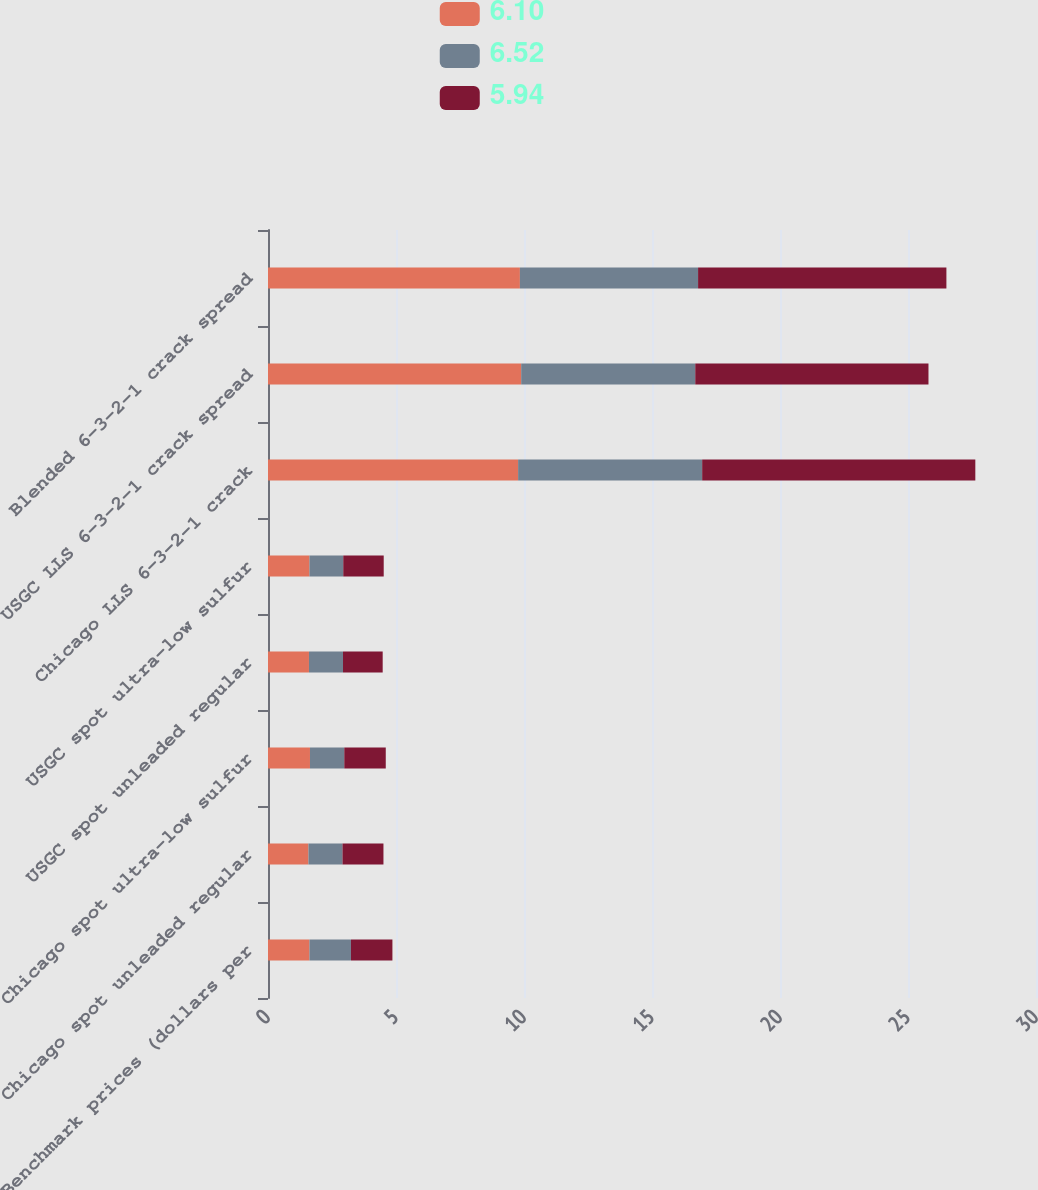Convert chart to OTSL. <chart><loc_0><loc_0><loc_500><loc_500><stacked_bar_chart><ecel><fcel>Benchmark prices (dollars per<fcel>Chicago spot unleaded regular<fcel>Chicago spot ultra-low sulfur<fcel>USGC spot unleaded regular<fcel>USGC spot ultra-low sulfur<fcel>Chicago LLS 6-3-2-1 crack<fcel>USGC LLS 6-3-2-1 crack spread<fcel>Blended 6-3-2-1 crack spread<nl><fcel>6.1<fcel>1.62<fcel>1.58<fcel>1.64<fcel>1.6<fcel>1.62<fcel>9.77<fcel>9.89<fcel>9.84<nl><fcel>6.52<fcel>1.62<fcel>1.33<fcel>1.34<fcel>1.33<fcel>1.32<fcel>7.19<fcel>6.8<fcel>6.96<nl><fcel>5.94<fcel>1.62<fcel>1.6<fcel>1.62<fcel>1.55<fcel>1.58<fcel>10.67<fcel>9.11<fcel>9.7<nl></chart> 